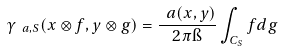Convert formula to latex. <formula><loc_0><loc_0><loc_500><loc_500>\gamma _ { \ a , S } ( x \otimes f , y \otimes g ) = \frac { \ a ( x , y ) } { 2 \pi \i } \int _ { C _ { S } } f d g</formula> 